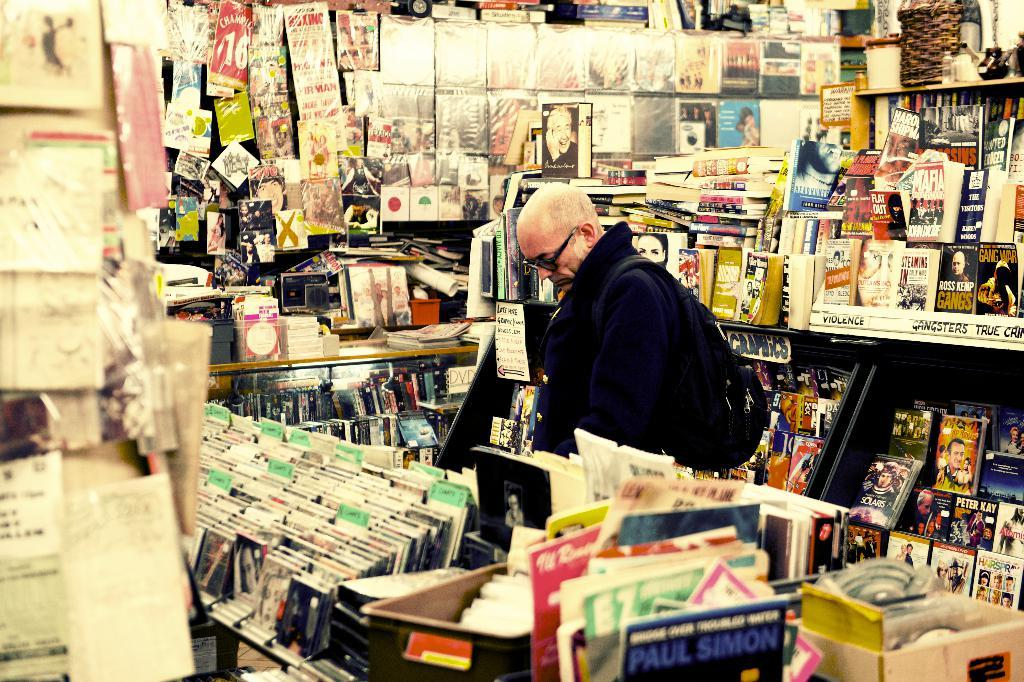<image>
Describe the image concisely. A man browses records in a record shop, including one by Paul Simon. 